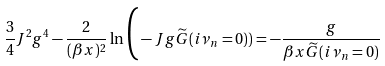<formula> <loc_0><loc_0><loc_500><loc_500>\frac { 3 } { 4 } J ^ { 2 } g ^ { 4 } - \frac { 2 } { ( \beta x ) ^ { 2 } } \ln \Big ( - J g \widetilde { G } ( i \nu _ { n } = 0 ) ) = - \frac { g } { \beta x \widetilde { G } ( i \nu _ { n } = 0 ) }</formula> 